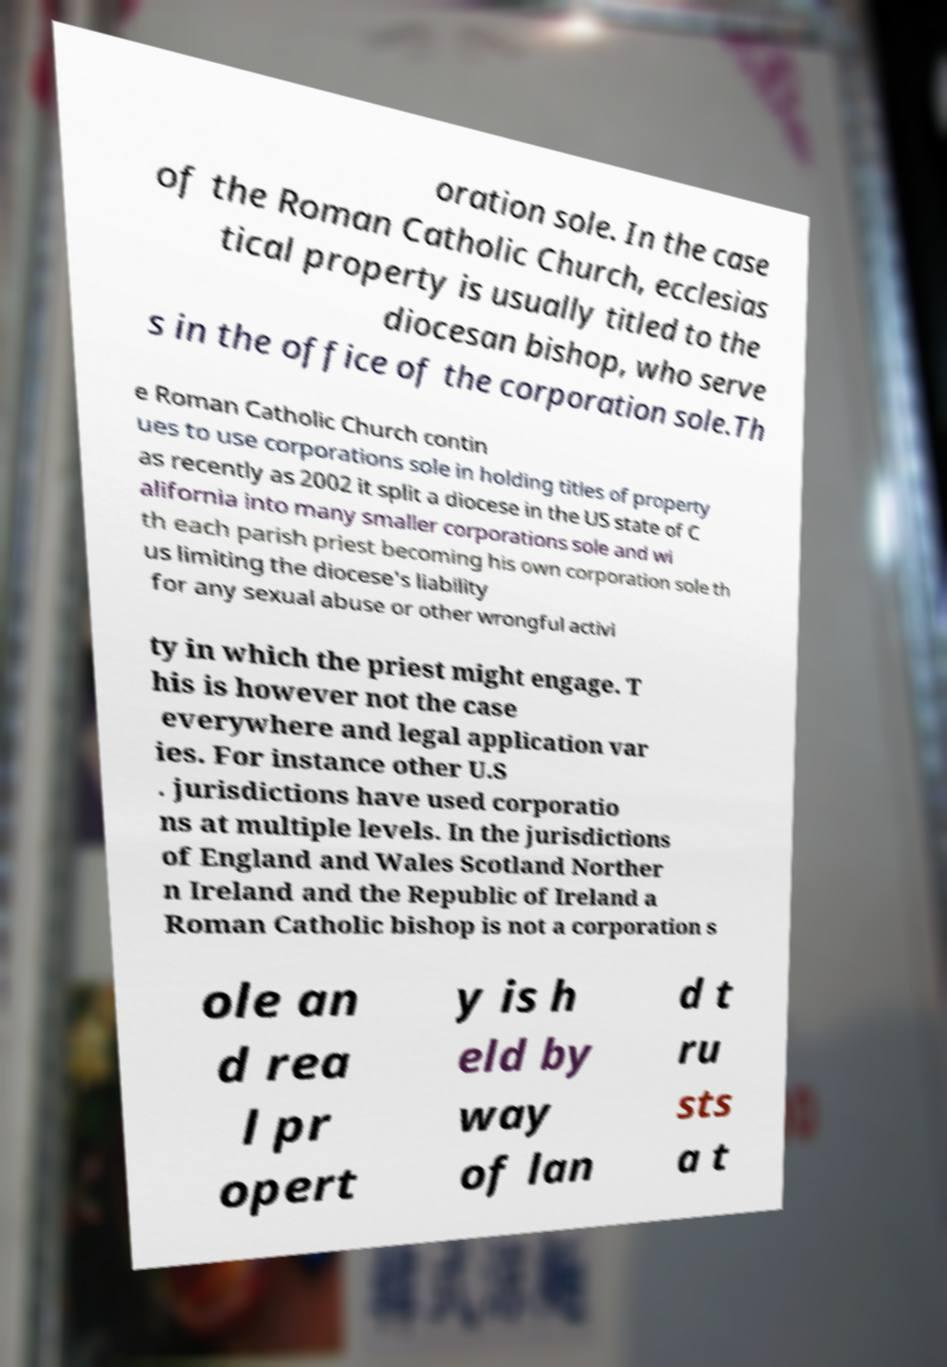Can you accurately transcribe the text from the provided image for me? oration sole. In the case of the Roman Catholic Church, ecclesias tical property is usually titled to the diocesan bishop, who serve s in the office of the corporation sole.Th e Roman Catholic Church contin ues to use corporations sole in holding titles of property as recently as 2002 it split a diocese in the US state of C alifornia into many smaller corporations sole and wi th each parish priest becoming his own corporation sole th us limiting the diocese's liability for any sexual abuse or other wrongful activi ty in which the priest might engage. T his is however not the case everywhere and legal application var ies. For instance other U.S . jurisdictions have used corporatio ns at multiple levels. In the jurisdictions of England and Wales Scotland Norther n Ireland and the Republic of Ireland a Roman Catholic bishop is not a corporation s ole an d rea l pr opert y is h eld by way of lan d t ru sts a t 